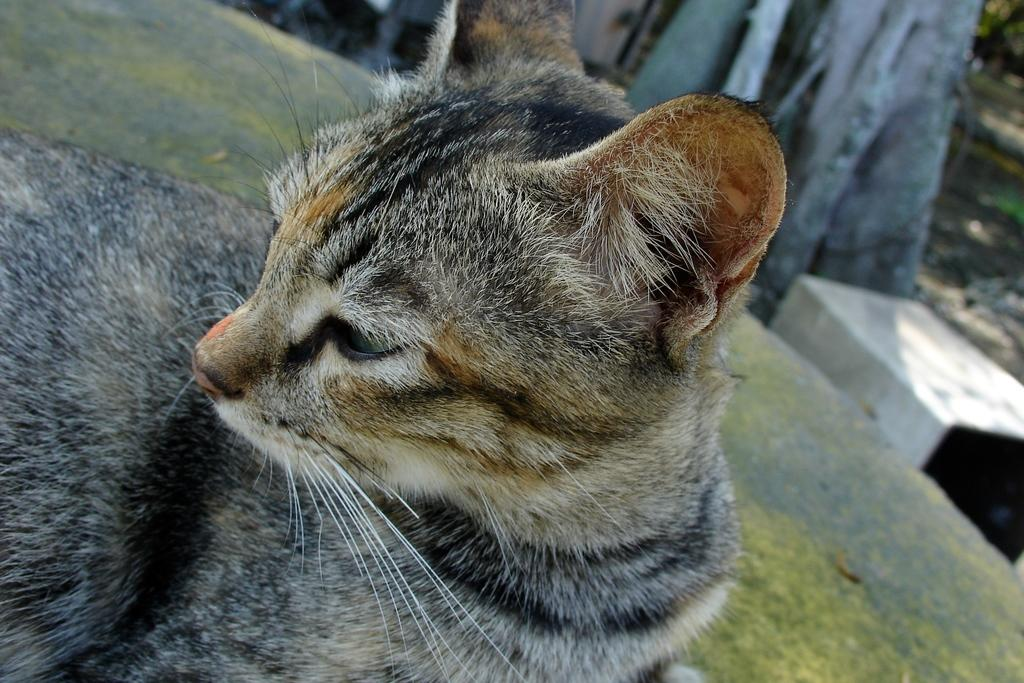What animal can be seen on the ground in the image? There is a cat on the ground in the image. What type of object is visible in the background of the image? There is a bench in the background of the image. What natural element is present in the background of the image? There is a tree trunk in the background of the image. Can you determine the time of day when the image was taken? The image was likely taken during the day, as there is sufficient light to see the cat, bench, and tree trunk clearly. What type of scent is emanating from the cat's throat in the image? There is no indication of a scent or any reference to a throat in the image; it simply shows a cat on the ground. 